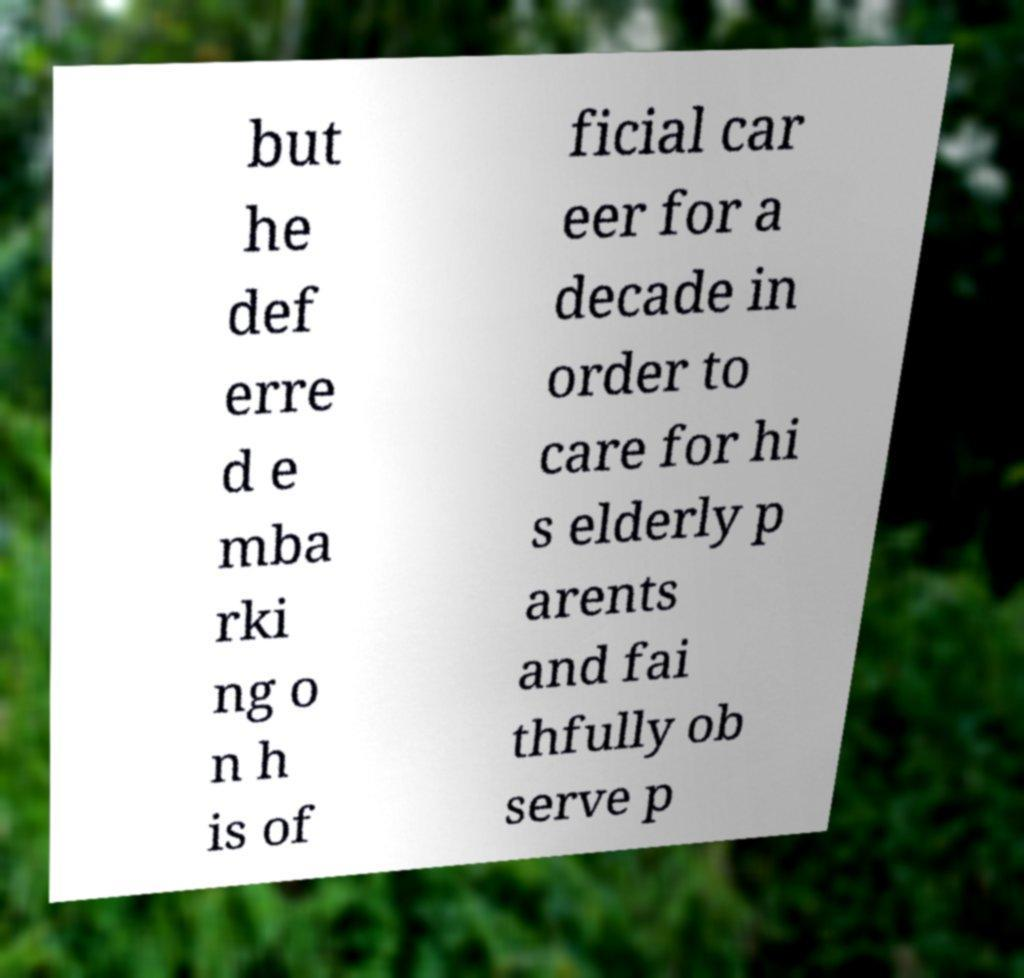Could you assist in decoding the text presented in this image and type it out clearly? but he def erre d e mba rki ng o n h is of ficial car eer for a decade in order to care for hi s elderly p arents and fai thfully ob serve p 